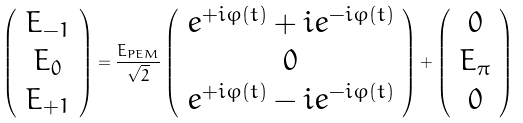<formula> <loc_0><loc_0><loc_500><loc_500>\left ( \begin{array} { c } E _ { - 1 } \\ E _ { 0 } \\ E _ { + 1 } \\ \end{array} \right ) = \frac { E _ { P E M } } { \sqrt { 2 } } \left ( \begin{array} { c } e ^ { + i \varphi ( t ) } + i e ^ { - i \varphi ( t ) } \\ 0 \\ e ^ { + i \varphi ( t ) } - i e ^ { - i \varphi ( t ) } \\ \end{array} \right ) + \left ( \begin{array} { c } 0 \\ E _ { \pi } \\ 0 \\ \end{array} \right )</formula> 